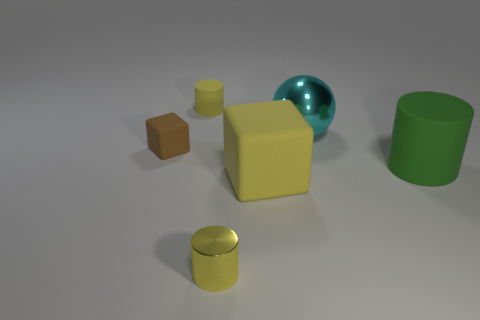Can you tell me the lighting direction in the image based on the shadows? Certainly, the lighting appears to be coming from the upper right-hand side of the composition. This is indicated by the shadows cast to the lower left side of each object. The shadows are soft and suggest a diffused light source, giving the scene a calm and even illumination. 